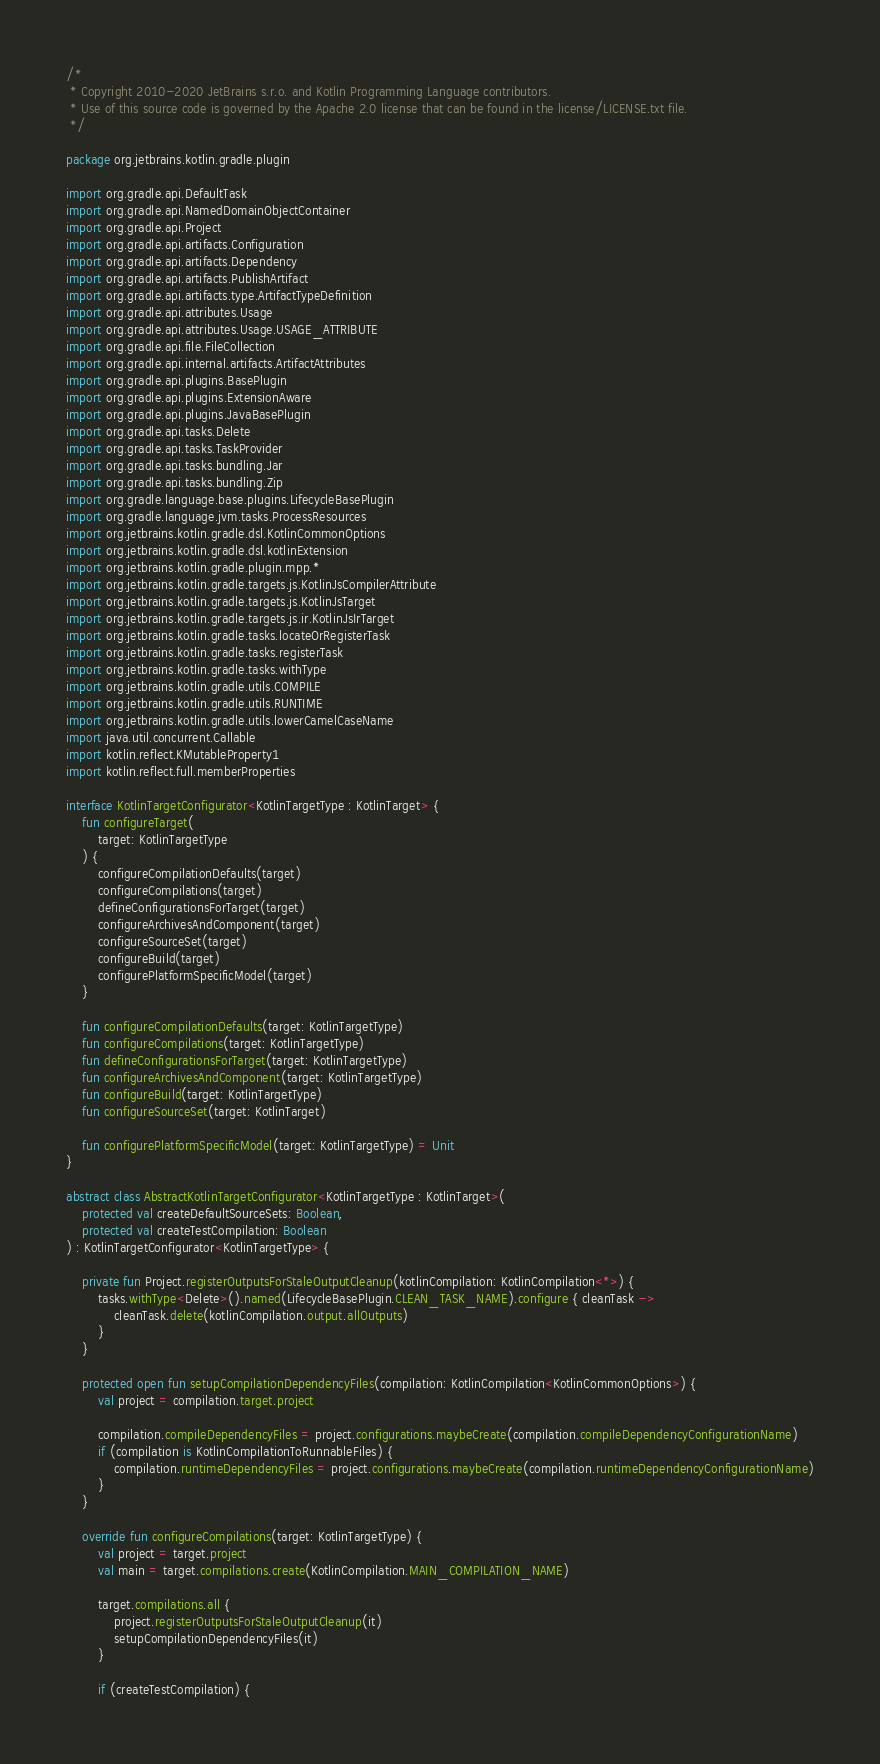<code> <loc_0><loc_0><loc_500><loc_500><_Kotlin_>/*
 * Copyright 2010-2020 JetBrains s.r.o. and Kotlin Programming Language contributors.
 * Use of this source code is governed by the Apache 2.0 license that can be found in the license/LICENSE.txt file.
 */

package org.jetbrains.kotlin.gradle.plugin

import org.gradle.api.DefaultTask
import org.gradle.api.NamedDomainObjectContainer
import org.gradle.api.Project
import org.gradle.api.artifacts.Configuration
import org.gradle.api.artifacts.Dependency
import org.gradle.api.artifacts.PublishArtifact
import org.gradle.api.artifacts.type.ArtifactTypeDefinition
import org.gradle.api.attributes.Usage
import org.gradle.api.attributes.Usage.USAGE_ATTRIBUTE
import org.gradle.api.file.FileCollection
import org.gradle.api.internal.artifacts.ArtifactAttributes
import org.gradle.api.plugins.BasePlugin
import org.gradle.api.plugins.ExtensionAware
import org.gradle.api.plugins.JavaBasePlugin
import org.gradle.api.tasks.Delete
import org.gradle.api.tasks.TaskProvider
import org.gradle.api.tasks.bundling.Jar
import org.gradle.api.tasks.bundling.Zip
import org.gradle.language.base.plugins.LifecycleBasePlugin
import org.gradle.language.jvm.tasks.ProcessResources
import org.jetbrains.kotlin.gradle.dsl.KotlinCommonOptions
import org.jetbrains.kotlin.gradle.dsl.kotlinExtension
import org.jetbrains.kotlin.gradle.plugin.mpp.*
import org.jetbrains.kotlin.gradle.targets.js.KotlinJsCompilerAttribute
import org.jetbrains.kotlin.gradle.targets.js.KotlinJsTarget
import org.jetbrains.kotlin.gradle.targets.js.ir.KotlinJsIrTarget
import org.jetbrains.kotlin.gradle.tasks.locateOrRegisterTask
import org.jetbrains.kotlin.gradle.tasks.registerTask
import org.jetbrains.kotlin.gradle.tasks.withType
import org.jetbrains.kotlin.gradle.utils.COMPILE
import org.jetbrains.kotlin.gradle.utils.RUNTIME
import org.jetbrains.kotlin.gradle.utils.lowerCamelCaseName
import java.util.concurrent.Callable
import kotlin.reflect.KMutableProperty1
import kotlin.reflect.full.memberProperties

interface KotlinTargetConfigurator<KotlinTargetType : KotlinTarget> {
    fun configureTarget(
        target: KotlinTargetType
    ) {
        configureCompilationDefaults(target)
        configureCompilations(target)
        defineConfigurationsForTarget(target)
        configureArchivesAndComponent(target)
        configureSourceSet(target)
        configureBuild(target)
        configurePlatformSpecificModel(target)
    }

    fun configureCompilationDefaults(target: KotlinTargetType)
    fun configureCompilations(target: KotlinTargetType)
    fun defineConfigurationsForTarget(target: KotlinTargetType)
    fun configureArchivesAndComponent(target: KotlinTargetType)
    fun configureBuild(target: KotlinTargetType)
    fun configureSourceSet(target: KotlinTarget)

    fun configurePlatformSpecificModel(target: KotlinTargetType) = Unit
}

abstract class AbstractKotlinTargetConfigurator<KotlinTargetType : KotlinTarget>(
    protected val createDefaultSourceSets: Boolean,
    protected val createTestCompilation: Boolean
) : KotlinTargetConfigurator<KotlinTargetType> {

    private fun Project.registerOutputsForStaleOutputCleanup(kotlinCompilation: KotlinCompilation<*>) {
        tasks.withType<Delete>().named(LifecycleBasePlugin.CLEAN_TASK_NAME).configure { cleanTask ->
            cleanTask.delete(kotlinCompilation.output.allOutputs)
        }
    }

    protected open fun setupCompilationDependencyFiles(compilation: KotlinCompilation<KotlinCommonOptions>) {
        val project = compilation.target.project

        compilation.compileDependencyFiles = project.configurations.maybeCreate(compilation.compileDependencyConfigurationName)
        if (compilation is KotlinCompilationToRunnableFiles) {
            compilation.runtimeDependencyFiles = project.configurations.maybeCreate(compilation.runtimeDependencyConfigurationName)
        }
    }

    override fun configureCompilations(target: KotlinTargetType) {
        val project = target.project
        val main = target.compilations.create(KotlinCompilation.MAIN_COMPILATION_NAME)

        target.compilations.all {
            project.registerOutputsForStaleOutputCleanup(it)
            setupCompilationDependencyFiles(it)
        }

        if (createTestCompilation) {</code> 